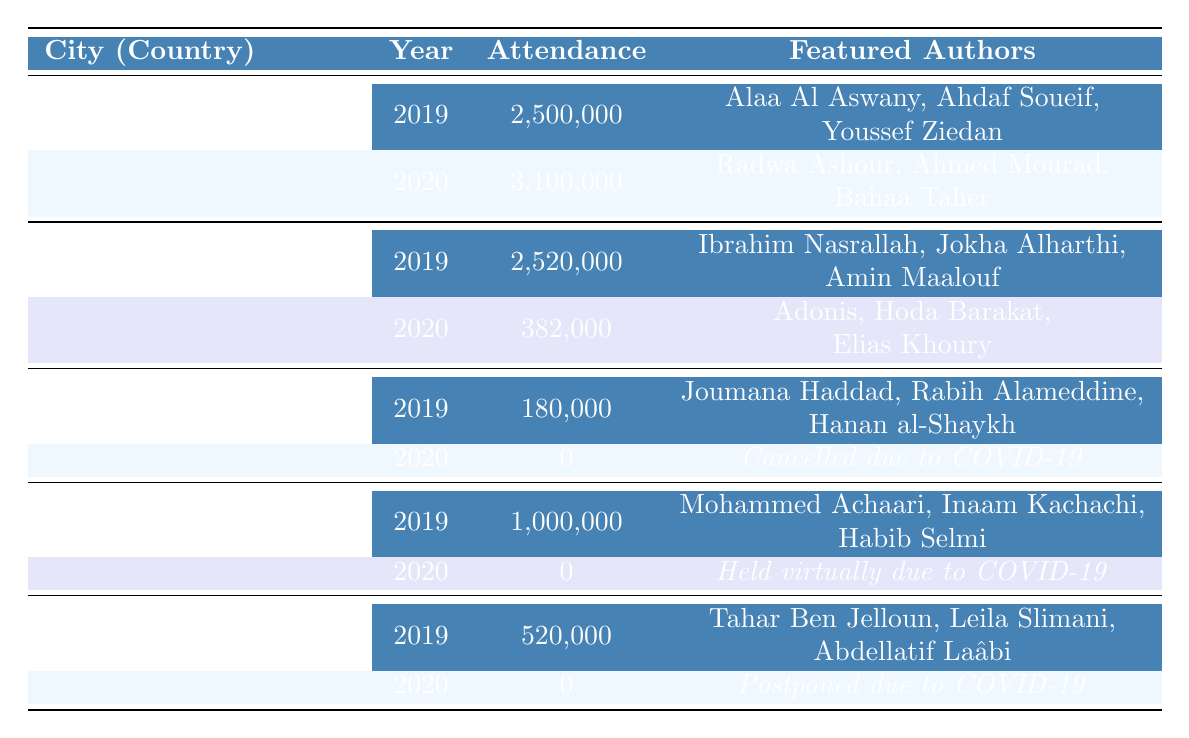What was the attendance at the Cairo International Book Fair in 2020? The table indicates that the attendance for the Cairo International Book Fair in 2020 was 3,100,000.
Answer: 3,100,000 Which city had the highest attendance in 2019? By comparing the attendance figures for 2019 across the cities listed, Cairo had the highest attendance with 2,500,000.
Answer: Cairo How many featured authors were there at the Sharjah International Book Fair in 2019? The event in 2019 had three featured authors listed: Ibrahim Nasrallah, Jokha Alharthi, and Amin Maalouf.
Answer: 3 Did the Abu Dhabi International Book Fair take place in 2020? According to the table, the event in 2020 was held virtually due to the COVID-19 pandemic, indicating that it did not take place in a traditional manner.
Answer: Yes What is the difference in attendance between the 2019 and 2020 Sharjah International Book Fair? The attendance in 2019 was 2,520,000, while in 2020 it dropped to 382,000. The difference is 2,520,000 - 382,000 = 2,138,000.
Answer: 2,138,000 Which city had the lowest attendance in 2019? By examining the attendance data, Beirut had the lowest attendance in 2019 with 180,000.
Answer: Beirut What was the total attendance for all festivals in 2019? Adding the attendance figures for 2019: 2,500,000 (Cairo) + 2,520,000 (Sharjah) + 180,000 (Beirut) + 1,000,000 (Abu Dhabi) + 520,000 (Casablanca) gives a total of 6,720,000.
Answer: 6,720,000 In how many festivals featured authors were there in 2020? The table shows that there are no featured authors listed for the Beirut, Abu Dhabi, and Casablanca festivals in 2020 due to cancellations or virtual hosting, while Sharjah had three authors. Thus, there was a total of 3 unique authors in 2020.
Answer: 3 Was the attendance at the Beirut International Arab Book Fair in 2020 different from 2019? According to the table, Beirut had an attendance of 180,000 in 2019 and 0 in 2020 due to cancellation. So attendance was different.
Answer: Yes What was the average attendance for all festivals in 2019? The total attendance in 2019 is 6,720,000, and there are 5 events. So the average attendance is 6,720,000 / 5 = 1,344,000.
Answer: 1,344,000 